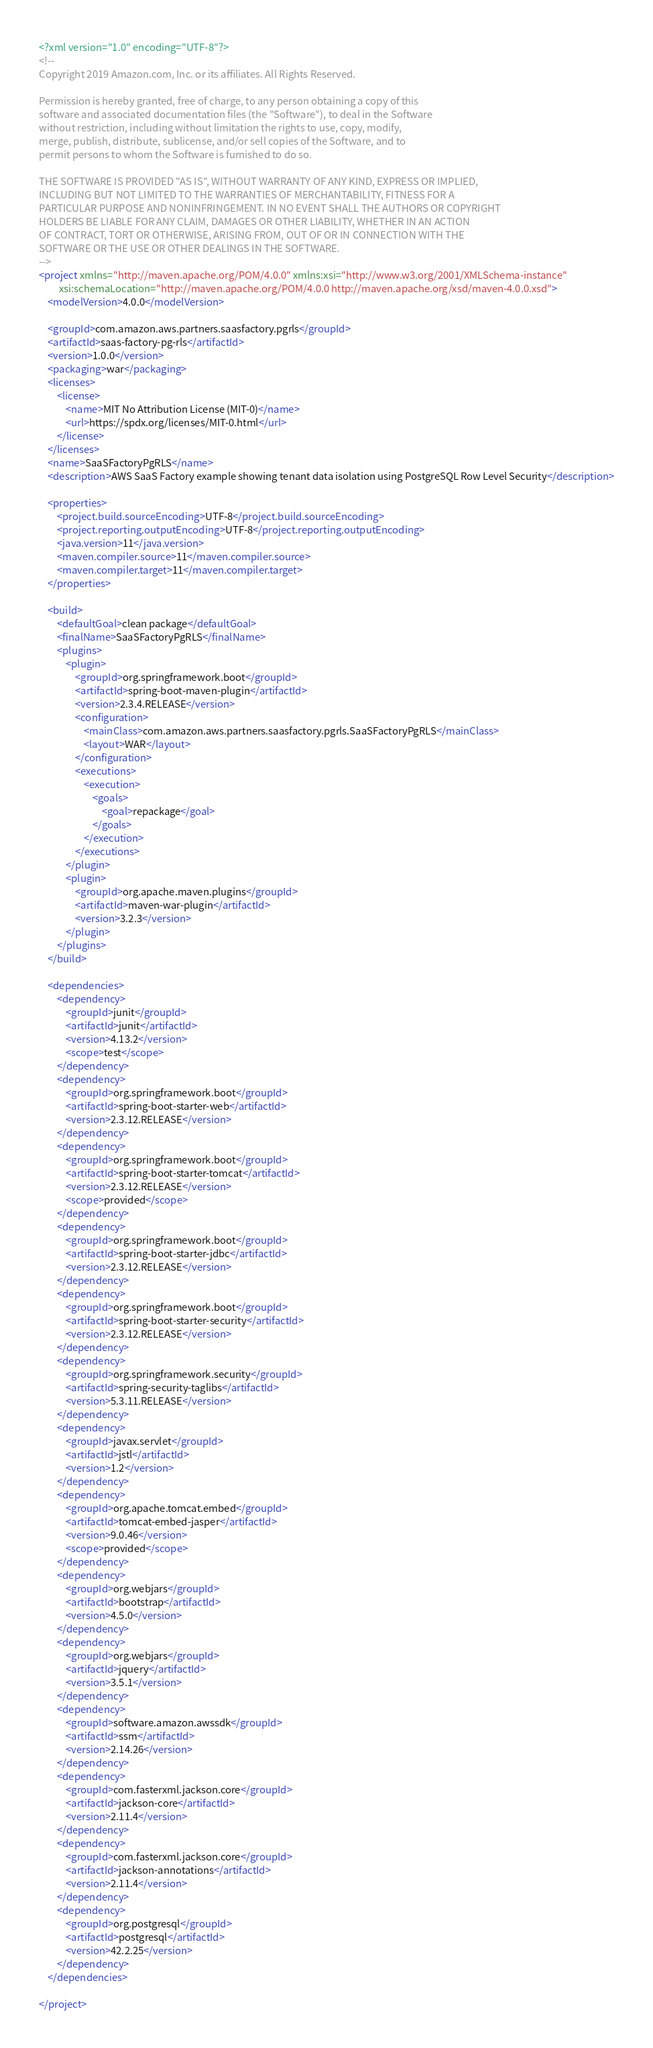Convert code to text. <code><loc_0><loc_0><loc_500><loc_500><_XML_><?xml version="1.0" encoding="UTF-8"?>
<!--
Copyright 2019 Amazon.com, Inc. or its affiliates. All Rights Reserved.

Permission is hereby granted, free of charge, to any person obtaining a copy of this
software and associated documentation files (the "Software"), to deal in the Software
without restriction, including without limitation the rights to use, copy, modify,
merge, publish, distribute, sublicense, and/or sell copies of the Software, and to
permit persons to whom the Software is furnished to do so.

THE SOFTWARE IS PROVIDED "AS IS", WITHOUT WARRANTY OF ANY KIND, EXPRESS OR IMPLIED,
INCLUDING BUT NOT LIMITED TO THE WARRANTIES OF MERCHANTABILITY, FITNESS FOR A
PARTICULAR PURPOSE AND NONINFRINGEMENT. IN NO EVENT SHALL THE AUTHORS OR COPYRIGHT
HOLDERS BE LIABLE FOR ANY CLAIM, DAMAGES OR OTHER LIABILITY, WHETHER IN AN ACTION
OF CONTRACT, TORT OR OTHERWISE, ARISING FROM, OUT OF OR IN CONNECTION WITH THE
SOFTWARE OR THE USE OR OTHER DEALINGS IN THE SOFTWARE.
-->
<project xmlns="http://maven.apache.org/POM/4.0.0" xmlns:xsi="http://www.w3.org/2001/XMLSchema-instance"
		 xsi:schemaLocation="http://maven.apache.org/POM/4.0.0 http://maven.apache.org/xsd/maven-4.0.0.xsd">
	<modelVersion>4.0.0</modelVersion>

	<groupId>com.amazon.aws.partners.saasfactory.pgrls</groupId>
	<artifactId>saas-factory-pg-rls</artifactId>
	<version>1.0.0</version>
	<packaging>war</packaging>
	<licenses>
		<license>
			<name>MIT No Attribution License (MIT-0)</name>
			<url>https://spdx.org/licenses/MIT-0.html</url>
		</license>
	</licenses>
	<name>SaaSFactoryPgRLS</name>
	<description>AWS SaaS Factory example showing tenant data isolation using PostgreSQL Row Level Security</description>

	<properties>
		<project.build.sourceEncoding>UTF-8</project.build.sourceEncoding>
		<project.reporting.outputEncoding>UTF-8</project.reporting.outputEncoding>
		<java.version>11</java.version>
		<maven.compiler.source>11</maven.compiler.source>
		<maven.compiler.target>11</maven.compiler.target>
	</properties>

	<build>
		<defaultGoal>clean package</defaultGoal>
		<finalName>SaaSFactoryPgRLS</finalName>
		<plugins>
			<plugin>
				<groupId>org.springframework.boot</groupId>
				<artifactId>spring-boot-maven-plugin</artifactId>
				<version>2.3.4.RELEASE</version>
				<configuration>
					<mainClass>com.amazon.aws.partners.saasfactory.pgrls.SaaSFactoryPgRLS</mainClass>
					<layout>WAR</layout>
				</configuration>
				<executions>
					<execution>
						<goals>
							<goal>repackage</goal>
						</goals>
					</execution>
				</executions>
			</plugin>
			<plugin>
				<groupId>org.apache.maven.plugins</groupId>
				<artifactId>maven-war-plugin</artifactId>
				<version>3.2.3</version>
			</plugin>
		</plugins>
	</build>

	<dependencies>
		<dependency>
			<groupId>junit</groupId>
			<artifactId>junit</artifactId>
			<version>4.13.2</version>
			<scope>test</scope>
		</dependency>
		<dependency>
			<groupId>org.springframework.boot</groupId>
			<artifactId>spring-boot-starter-web</artifactId>
			<version>2.3.12.RELEASE</version>
		</dependency>
		<dependency>
			<groupId>org.springframework.boot</groupId>
			<artifactId>spring-boot-starter-tomcat</artifactId>
			<version>2.3.12.RELEASE</version>
			<scope>provided</scope>
		</dependency>
		<dependency>
			<groupId>org.springframework.boot</groupId>
			<artifactId>spring-boot-starter-jdbc</artifactId>
			<version>2.3.12.RELEASE</version>
		</dependency>
		<dependency>
			<groupId>org.springframework.boot</groupId>
			<artifactId>spring-boot-starter-security</artifactId>
			<version>2.3.12.RELEASE</version>
		</dependency>
		<dependency>
			<groupId>org.springframework.security</groupId>
			<artifactId>spring-security-taglibs</artifactId>
			<version>5.3.11.RELEASE</version>
		</dependency>
		<dependency>
			<groupId>javax.servlet</groupId>
			<artifactId>jstl</artifactId>
			<version>1.2</version>
		</dependency>
		<dependency>
			<groupId>org.apache.tomcat.embed</groupId>
			<artifactId>tomcat-embed-jasper</artifactId>
			<version>9.0.46</version>
			<scope>provided</scope>
		</dependency>
		<dependency>
			<groupId>org.webjars</groupId>
			<artifactId>bootstrap</artifactId>
			<version>4.5.0</version>
		</dependency>
		<dependency>
			<groupId>org.webjars</groupId>
			<artifactId>jquery</artifactId>
			<version>3.5.1</version>
		</dependency>
		<dependency>
			<groupId>software.amazon.awssdk</groupId>
			<artifactId>ssm</artifactId>
			<version>2.14.26</version>
		</dependency>
		<dependency>
			<groupId>com.fasterxml.jackson.core</groupId>
			<artifactId>jackson-core</artifactId>
			<version>2.11.4</version>
		</dependency>
		<dependency>
			<groupId>com.fasterxml.jackson.core</groupId>
			<artifactId>jackson-annotations</artifactId>
			<version>2.11.4</version>
		</dependency>
		<dependency>
			<groupId>org.postgresql</groupId>
			<artifactId>postgresql</artifactId>
			<version>42.2.25</version>
		</dependency>
	</dependencies>

</project>
</code> 